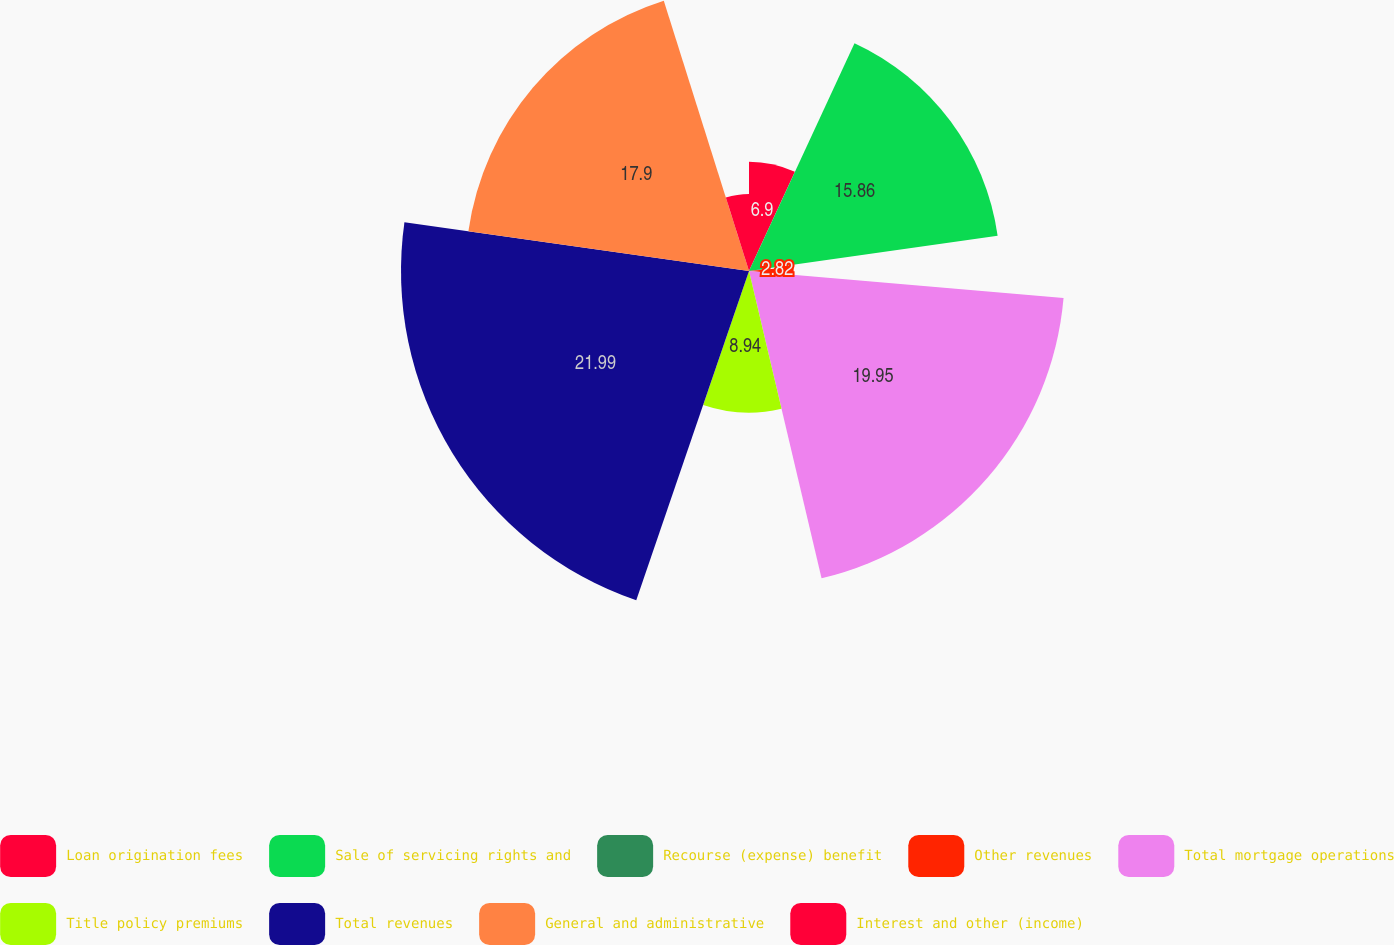Convert chart to OTSL. <chart><loc_0><loc_0><loc_500><loc_500><pie_chart><fcel>Loan origination fees<fcel>Sale of servicing rights and<fcel>Recourse (expense) benefit<fcel>Other revenues<fcel>Total mortgage operations<fcel>Title policy premiums<fcel>Total revenues<fcel>General and administrative<fcel>Interest and other (income)<nl><fcel>6.9%<fcel>15.86%<fcel>0.78%<fcel>2.82%<fcel>19.94%<fcel>8.94%<fcel>21.98%<fcel>17.9%<fcel>4.86%<nl></chart> 